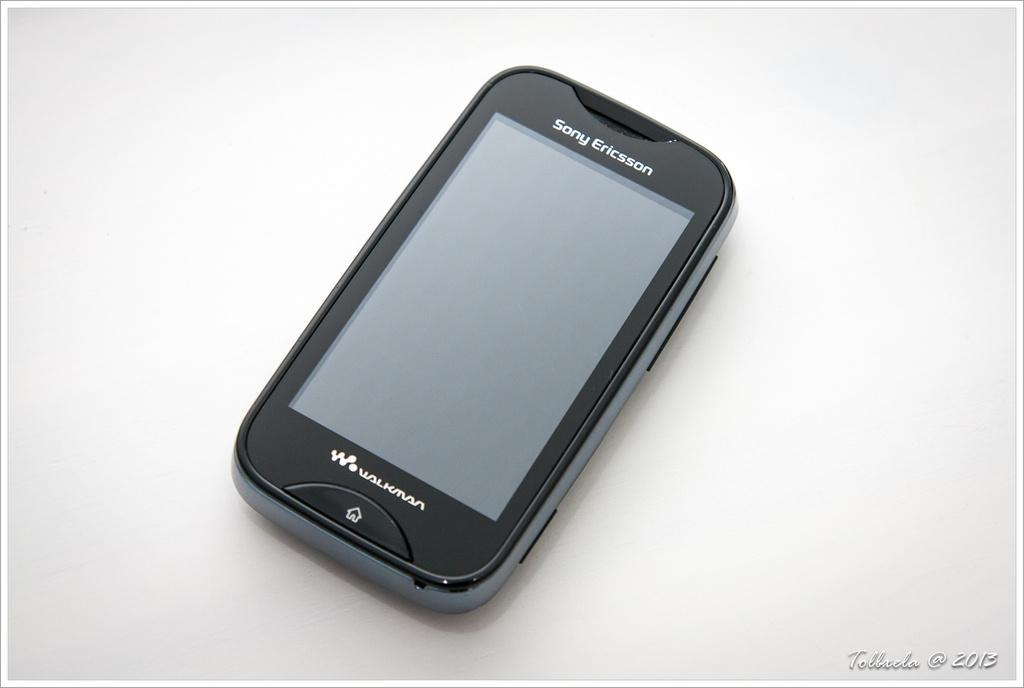What electronic device is visible in the image? There is a mobile phone in the image. Where is the mobile phone located? The mobile phone is on a table. What brand is the mobile phone? The mobile phone has "Sony Ericsson" written on it. What type of fruit is being used to make a pear stew in the image? There is no fruit or stew present in the image; it only features a mobile phone on a table. 